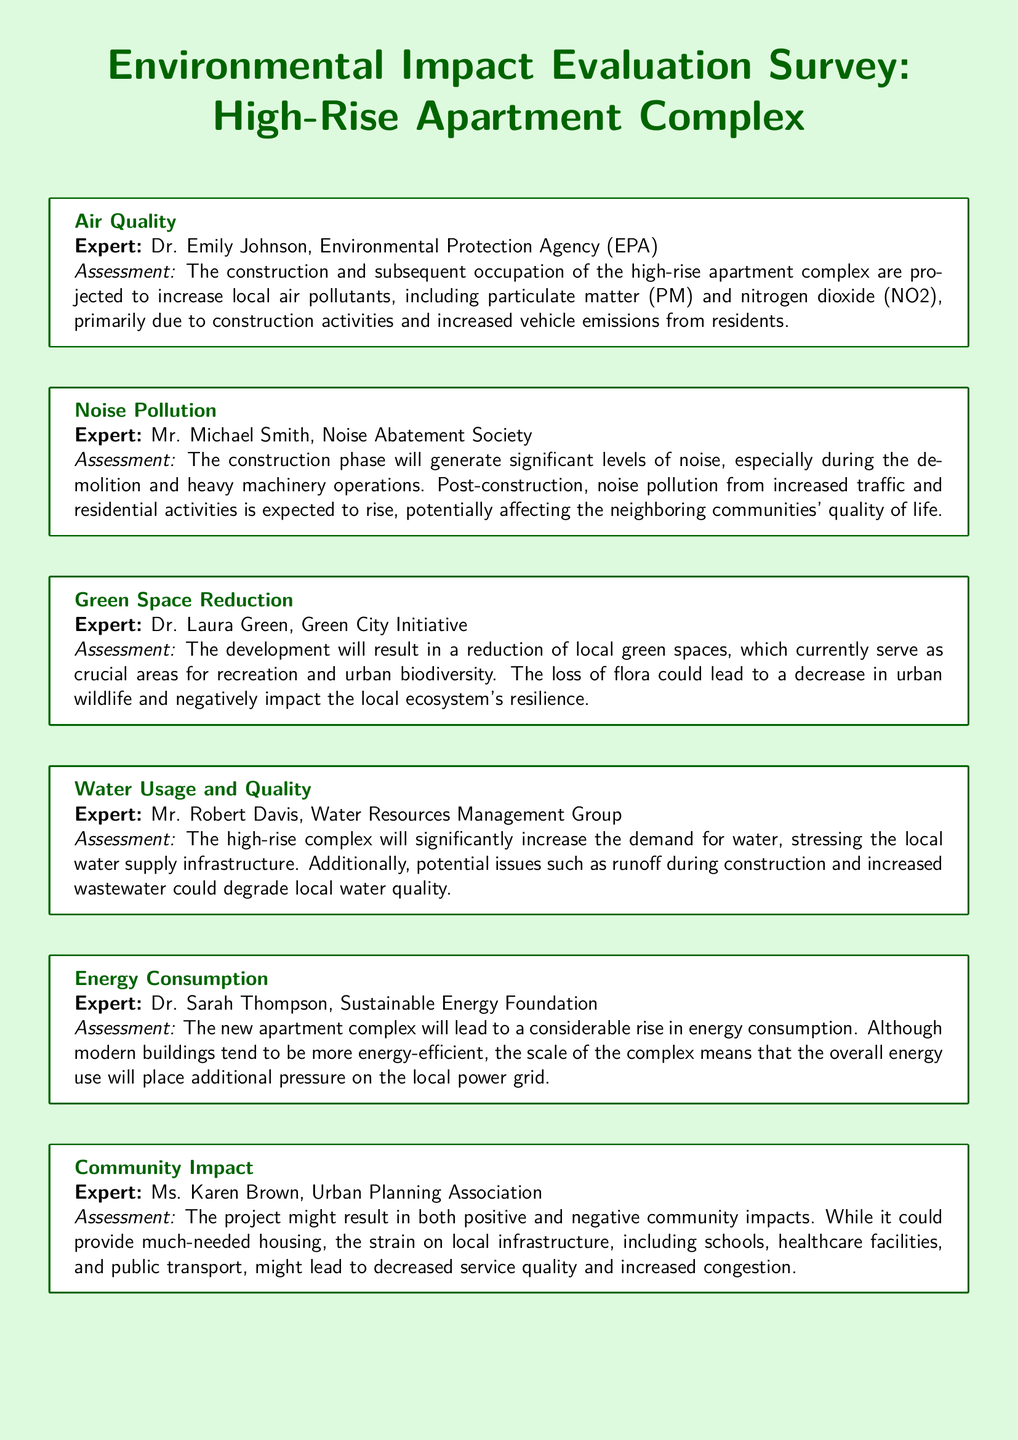What is the main environmental concern related to air quality? The assessment highlights that construction and occupation will increase local air pollutants.
Answer: air pollutants Who assessed the noise pollution impact? The document lists Mr. Michael Smith as the expert who assessed noise pollution.
Answer: Mr. Michael Smith What specific type of pollution is expected to rise due to increased traffic? The assessment mentions that noise pollution is expected to rise from increased traffic.
Answer: noise pollution What will the high-rise complex significantly increase the demand for? The document states that the development will increase the demand for water.
Answer: water Which expert evaluated the impact of the development on green spaces? Dr. Laura Green is identified as the expert evaluating green space reduction.
Answer: Dr. Laura Green What type of society is associated with the assessment of noise pollution? The document refers to the Noise Abatement Society in relation to noise pollution assessment.
Answer: Noise Abatement Society Which assessment includes the potential degradation of local water quality? Mr. Robert Davis's assessment discusses issues related to water quality degradation.
Answer: water quality degradation What does the Urban Planning Association's assessment cover? The assessment from the Urban Planning Association covers community impacts of the project.
Answer: community impacts During which phase is significant noise generated according to the assessments? The document specifies that significant noise is generated during the construction phase.
Answer: construction phase 